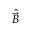Convert formula to latex. <formula><loc_0><loc_0><loc_500><loc_500>\hat { \vec { B } }</formula> 